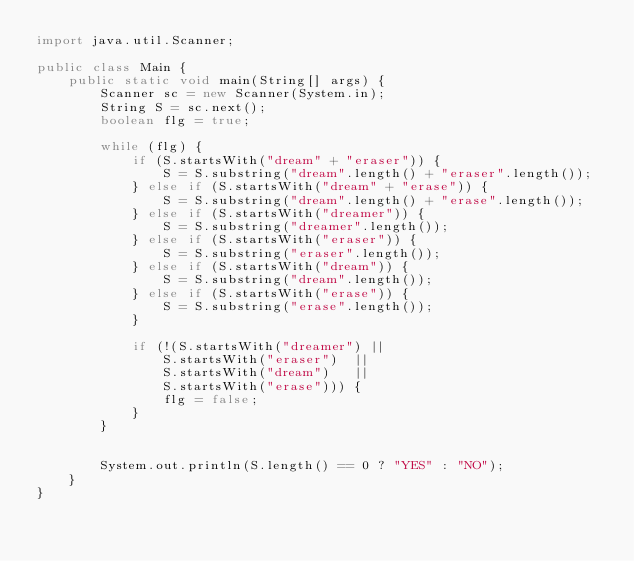Convert code to text. <code><loc_0><loc_0><loc_500><loc_500><_Java_>import java.util.Scanner;

public class Main {
	public static void main(String[] args) {
		Scanner sc = new Scanner(System.in);
		String S = sc.next();
		boolean flg = true;

		while (flg) {
			if (S.startsWith("dream" + "eraser")) {
				S = S.substring("dream".length() + "eraser".length());
			} else if (S.startsWith("dream" + "erase")) {
				S = S.substring("dream".length() + "erase".length());
			} else if (S.startsWith("dreamer")) {
				S = S.substring("dreamer".length());
			} else if (S.startsWith("eraser")) {
				S = S.substring("eraser".length());
			} else if (S.startsWith("dream")) {
				S = S.substring("dream".length());
			} else if (S.startsWith("erase")) {
				S = S.substring("erase".length());
			}

			if (!(S.startsWith("dreamer") ||
				S.startsWith("eraser")  ||
				S.startsWith("dream")   ||
				S.startsWith("erase"))) {
				flg = false;
			}
		}


		System.out.println(S.length() == 0 ? "YES" : "NO");
	}
}
</code> 